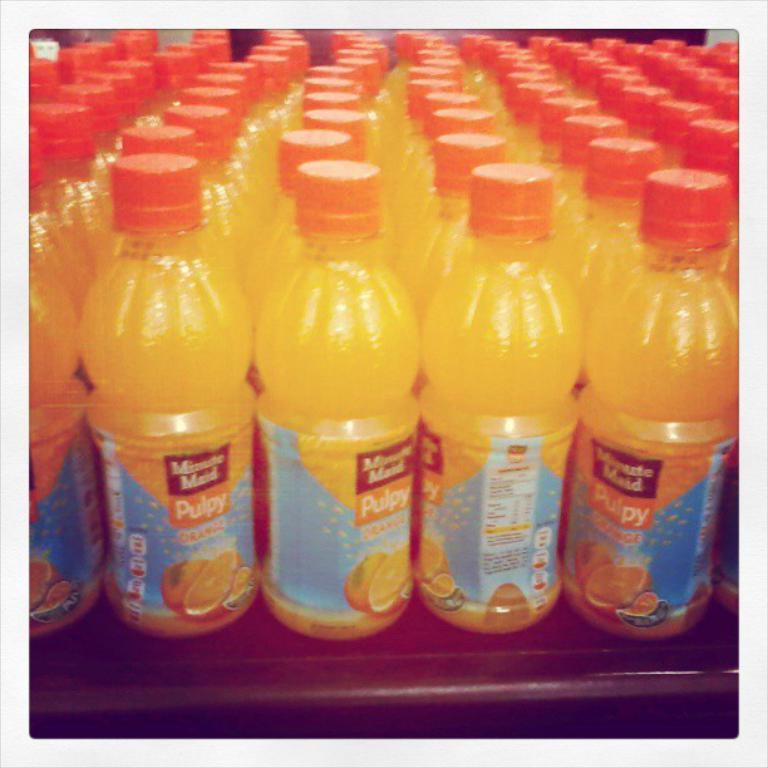What objects are present in the image? There are bottles in the image. How are the bottles arranged? The bottles are arranged in an order. What color are the caps of the bottles? The caps of the bottles are in orange color. Is there a tray with fire on it in the image? No, there is no tray or fire present in the image. 